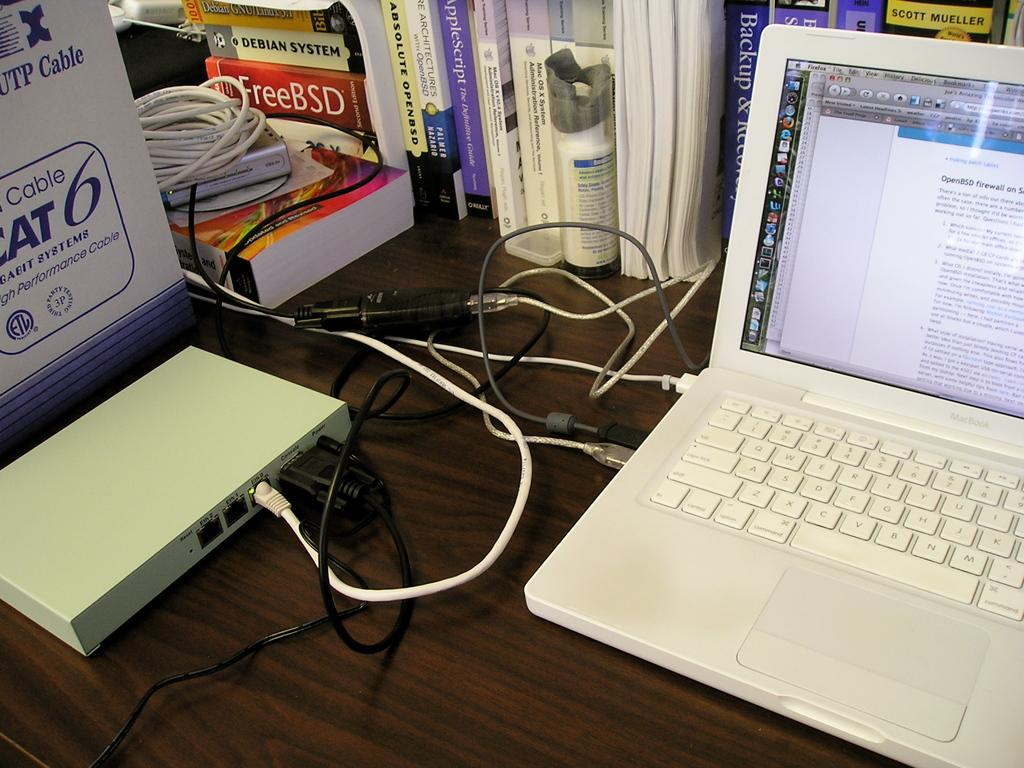<image>
Summarize the visual content of the image. Laptop sits on a wooden table filled with book including one reading FreeBSD. 